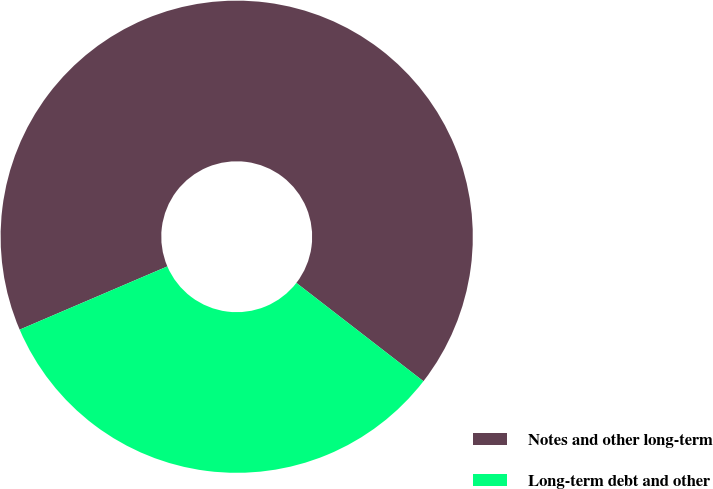Convert chart to OTSL. <chart><loc_0><loc_0><loc_500><loc_500><pie_chart><fcel>Notes and other long-term<fcel>Long-term debt and other<nl><fcel>66.92%<fcel>33.08%<nl></chart> 